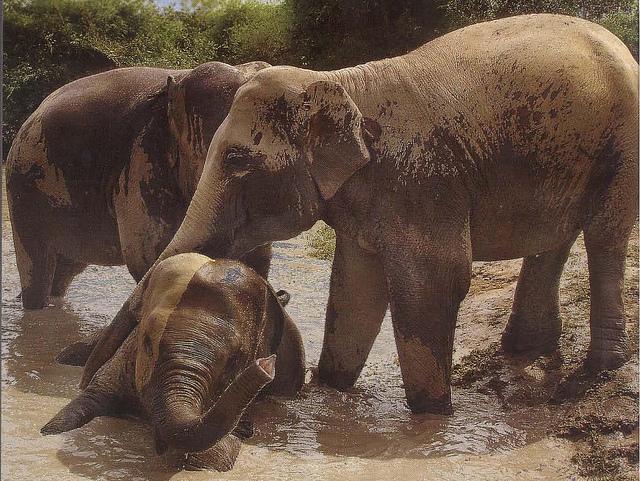Which deity looks like these animals?
Select the accurate answer and provide justification: `Answer: choice
Rationale: srationale.`
Options: Anubis, artemis, ganesh, set. Answer: ganesh.
Rationale: The animals are elephants. the elephant is a representation of a popular hindu deity. 